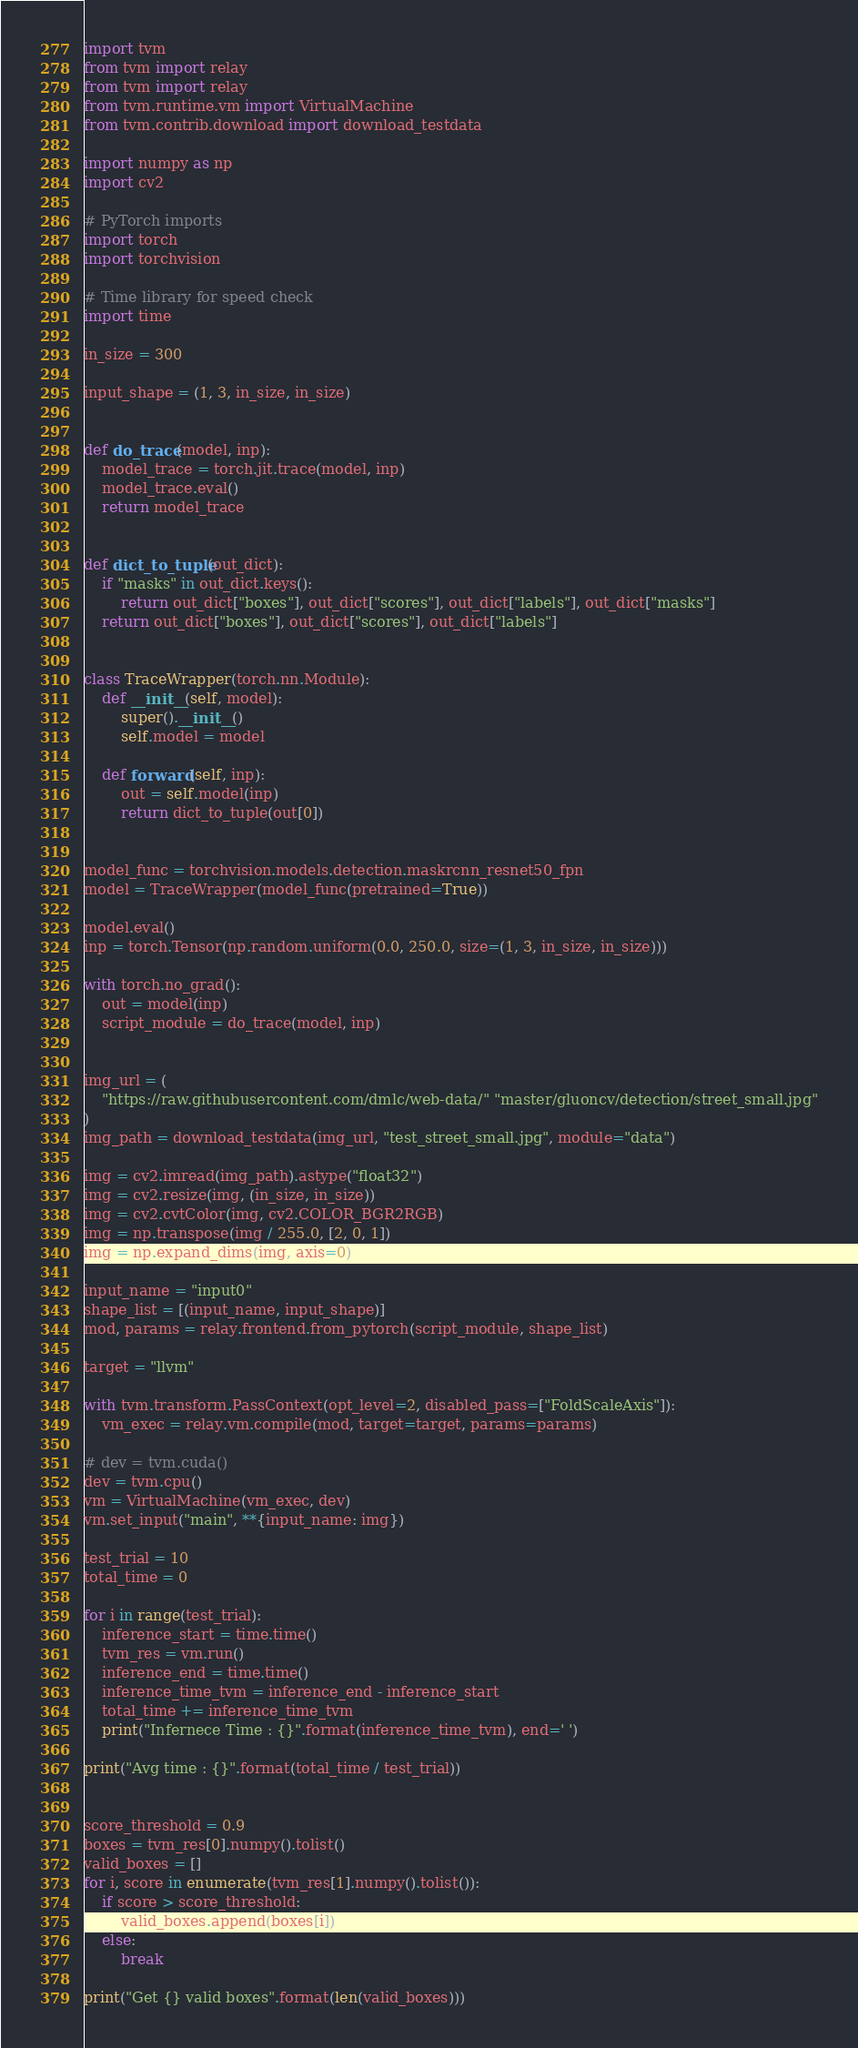Convert code to text. <code><loc_0><loc_0><loc_500><loc_500><_Python_>import tvm
from tvm import relay
from tvm import relay
from tvm.runtime.vm import VirtualMachine
from tvm.contrib.download import download_testdata

import numpy as np
import cv2

# PyTorch imports
import torch
import torchvision

# Time library for speed check
import time

in_size = 300

input_shape = (1, 3, in_size, in_size)


def do_trace(model, inp):
    model_trace = torch.jit.trace(model, inp)
    model_trace.eval()
    return model_trace


def dict_to_tuple(out_dict):
    if "masks" in out_dict.keys():
        return out_dict["boxes"], out_dict["scores"], out_dict["labels"], out_dict["masks"]
    return out_dict["boxes"], out_dict["scores"], out_dict["labels"]


class TraceWrapper(torch.nn.Module):
    def __init__(self, model):
        super().__init__()
        self.model = model

    def forward(self, inp):
        out = self.model(inp)
        return dict_to_tuple(out[0])


model_func = torchvision.models.detection.maskrcnn_resnet50_fpn
model = TraceWrapper(model_func(pretrained=True))

model.eval()
inp = torch.Tensor(np.random.uniform(0.0, 250.0, size=(1, 3, in_size, in_size)))

with torch.no_grad():
    out = model(inp)
    script_module = do_trace(model, inp)
    

img_url = (
    "https://raw.githubusercontent.com/dmlc/web-data/" "master/gluoncv/detection/street_small.jpg"
)
img_path = download_testdata(img_url, "test_street_small.jpg", module="data")

img = cv2.imread(img_path).astype("float32")
img = cv2.resize(img, (in_size, in_size))
img = cv2.cvtColor(img, cv2.COLOR_BGR2RGB)
img = np.transpose(img / 255.0, [2, 0, 1])
img = np.expand_dims(img, axis=0)

input_name = "input0"
shape_list = [(input_name, input_shape)]
mod, params = relay.frontend.from_pytorch(script_module, shape_list)

target = "llvm"

with tvm.transform.PassContext(opt_level=2, disabled_pass=["FoldScaleAxis"]):
    vm_exec = relay.vm.compile(mod, target=target, params=params)

# dev = tvm.cuda()
dev = tvm.cpu()
vm = VirtualMachine(vm_exec, dev)
vm.set_input("main", **{input_name: img})

test_trial = 10
total_time = 0

for i in range(test_trial):
    inference_start = time.time()
    tvm_res = vm.run()
    inference_end = time.time()
    inference_time_tvm = inference_end - inference_start
    total_time += inference_time_tvm
    print("Infernece Time : {}".format(inference_time_tvm), end=' ')

print("Avg time : {}".format(total_time / test_trial))


score_threshold = 0.9
boxes = tvm_res[0].numpy().tolist()
valid_boxes = []
for i, score in enumerate(tvm_res[1].numpy().tolist()):
    if score > score_threshold:
        valid_boxes.append(boxes[i])
    else:
        break

print("Get {} valid boxes".format(len(valid_boxes)))

</code> 